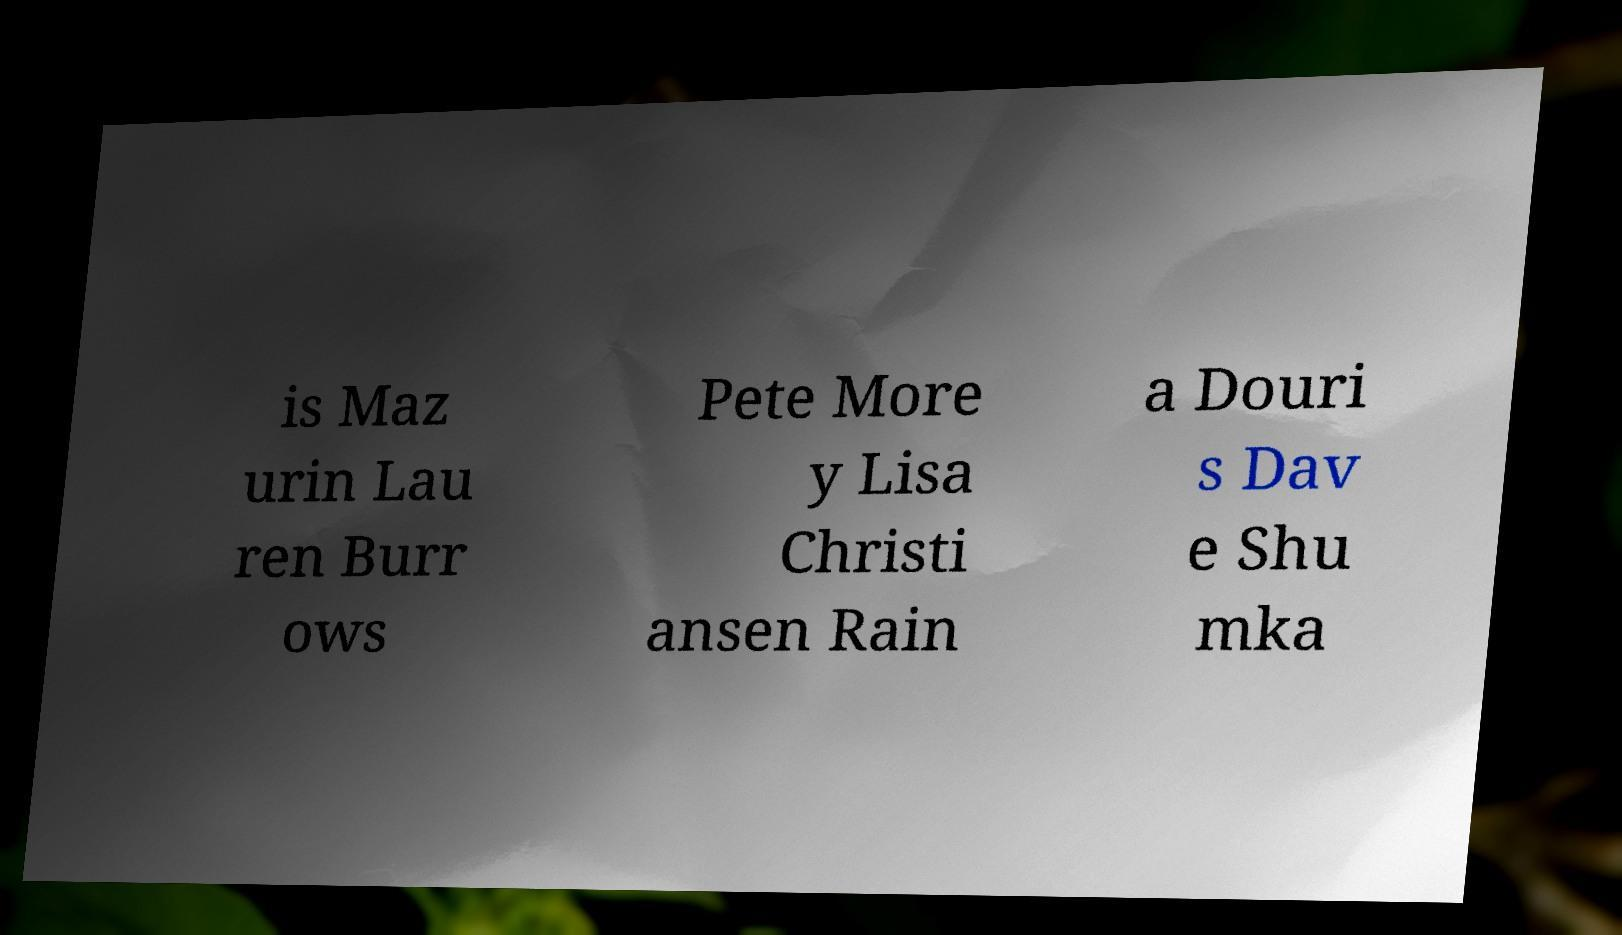For documentation purposes, I need the text within this image transcribed. Could you provide that? is Maz urin Lau ren Burr ows Pete More y Lisa Christi ansen Rain a Douri s Dav e Shu mka 